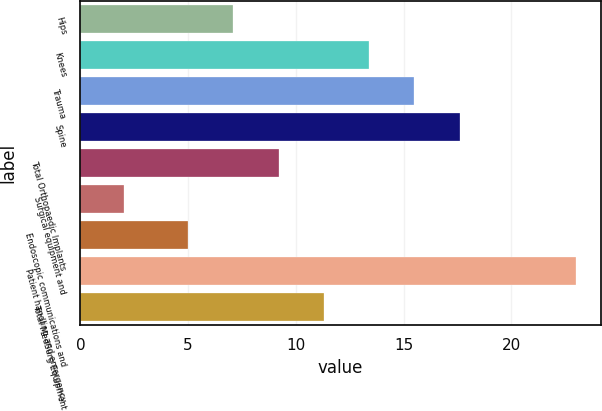<chart> <loc_0><loc_0><loc_500><loc_500><bar_chart><fcel>Hips<fcel>Knees<fcel>Trauma<fcel>Spine<fcel>Total Orthopaedic Implants<fcel>Surgical equipment and<fcel>Endoscopic communications and<fcel>Patient handling and emergency<fcel>Total MedSurg Equipment<nl><fcel>7.1<fcel>13.4<fcel>15.5<fcel>17.6<fcel>9.2<fcel>2<fcel>5<fcel>23<fcel>11.3<nl></chart> 